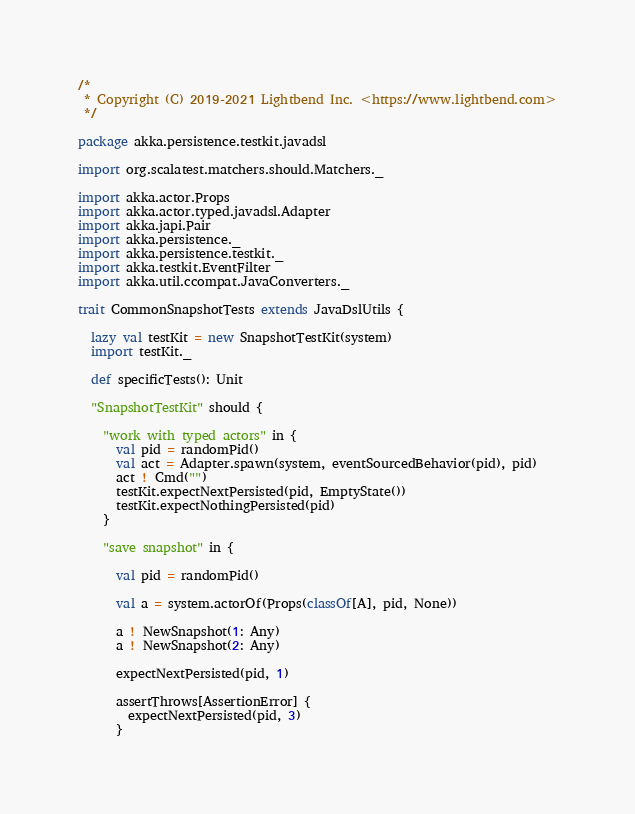Convert code to text. <code><loc_0><loc_0><loc_500><loc_500><_Scala_>/*
 * Copyright (C) 2019-2021 Lightbend Inc. <https://www.lightbend.com>
 */

package akka.persistence.testkit.javadsl

import org.scalatest.matchers.should.Matchers._

import akka.actor.Props
import akka.actor.typed.javadsl.Adapter
import akka.japi.Pair
import akka.persistence._
import akka.persistence.testkit._
import akka.testkit.EventFilter
import akka.util.ccompat.JavaConverters._

trait CommonSnapshotTests extends JavaDslUtils {

  lazy val testKit = new SnapshotTestKit(system)
  import testKit._

  def specificTests(): Unit

  "SnapshotTestKit" should {

    "work with typed actors" in {
      val pid = randomPid()
      val act = Adapter.spawn(system, eventSourcedBehavior(pid), pid)
      act ! Cmd("")
      testKit.expectNextPersisted(pid, EmptyState())
      testKit.expectNothingPersisted(pid)
    }

    "save snapshot" in {

      val pid = randomPid()

      val a = system.actorOf(Props(classOf[A], pid, None))

      a ! NewSnapshot(1: Any)
      a ! NewSnapshot(2: Any)

      expectNextPersisted(pid, 1)

      assertThrows[AssertionError] {
        expectNextPersisted(pid, 3)
      }
</code> 